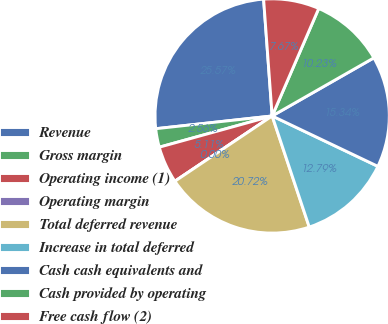<chart> <loc_0><loc_0><loc_500><loc_500><pie_chart><fcel>Revenue<fcel>Gross margin<fcel>Operating income (1)<fcel>Operating margin<fcel>Total deferred revenue<fcel>Increase in total deferred<fcel>Cash cash equivalents and<fcel>Cash provided by operating<fcel>Free cash flow (2)<nl><fcel>25.57%<fcel>2.56%<fcel>5.11%<fcel>0.0%<fcel>20.72%<fcel>12.79%<fcel>15.34%<fcel>10.23%<fcel>7.67%<nl></chart> 